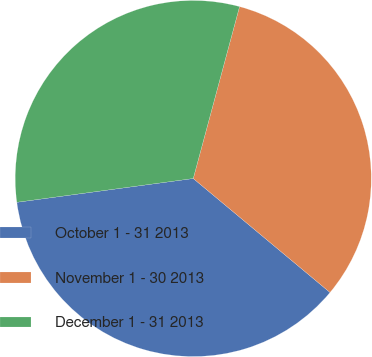<chart> <loc_0><loc_0><loc_500><loc_500><pie_chart><fcel>October 1 - 31 2013<fcel>November 1 - 30 2013<fcel>December 1 - 31 2013<nl><fcel>36.81%<fcel>31.87%<fcel>31.32%<nl></chart> 